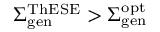<formula> <loc_0><loc_0><loc_500><loc_500>\Sigma _ { g e n } ^ { T h E S E } > \Sigma _ { g e n } ^ { o p t }</formula> 